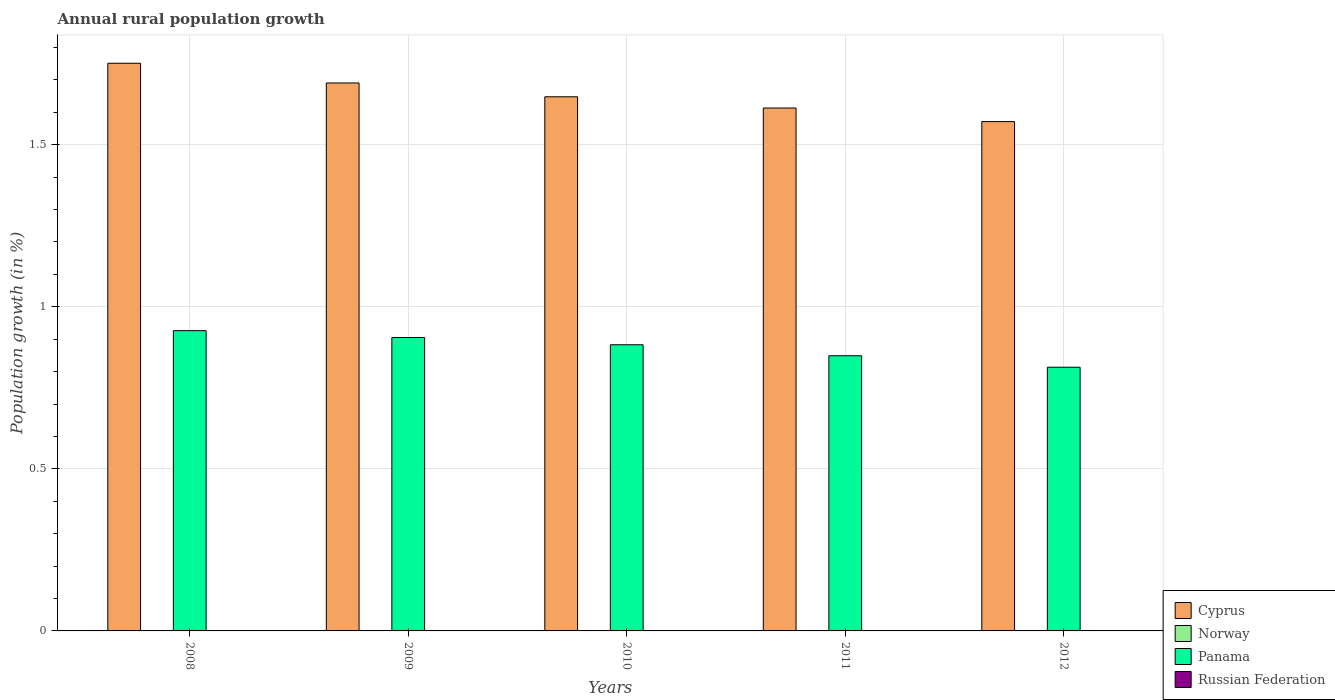How many different coloured bars are there?
Provide a short and direct response. 2. Are the number of bars per tick equal to the number of legend labels?
Offer a terse response. No. How many bars are there on the 2nd tick from the left?
Offer a terse response. 2. How many bars are there on the 4th tick from the right?
Ensure brevity in your answer.  2. Across all years, what is the maximum percentage of rural population growth in Panama?
Provide a succinct answer. 0.93. Across all years, what is the minimum percentage of rural population growth in Panama?
Give a very brief answer. 0.81. What is the difference between the percentage of rural population growth in Panama in 2008 and that in 2012?
Keep it short and to the point. 0.11. What is the difference between the percentage of rural population growth in Norway in 2011 and the percentage of rural population growth in Panama in 2009?
Ensure brevity in your answer.  -0.91. What is the average percentage of rural population growth in Cyprus per year?
Give a very brief answer. 1.65. In the year 2009, what is the difference between the percentage of rural population growth in Panama and percentage of rural population growth in Cyprus?
Provide a short and direct response. -0.79. In how many years, is the percentage of rural population growth in Panama greater than 1.6 %?
Offer a very short reply. 0. What is the ratio of the percentage of rural population growth in Cyprus in 2009 to that in 2012?
Provide a short and direct response. 1.08. Is the percentage of rural population growth in Cyprus in 2008 less than that in 2009?
Your response must be concise. No. Is the difference between the percentage of rural population growth in Panama in 2009 and 2010 greater than the difference between the percentage of rural population growth in Cyprus in 2009 and 2010?
Offer a very short reply. No. What is the difference between the highest and the second highest percentage of rural population growth in Cyprus?
Your answer should be very brief. 0.06. What is the difference between the highest and the lowest percentage of rural population growth in Panama?
Offer a very short reply. 0.11. In how many years, is the percentage of rural population growth in Cyprus greater than the average percentage of rural population growth in Cyprus taken over all years?
Keep it short and to the point. 2. Is the sum of the percentage of rural population growth in Cyprus in 2008 and 2009 greater than the maximum percentage of rural population growth in Panama across all years?
Keep it short and to the point. Yes. Is it the case that in every year, the sum of the percentage of rural population growth in Panama and percentage of rural population growth in Norway is greater than the sum of percentage of rural population growth in Russian Federation and percentage of rural population growth in Cyprus?
Offer a terse response. No. Is it the case that in every year, the sum of the percentage of rural population growth in Cyprus and percentage of rural population growth in Russian Federation is greater than the percentage of rural population growth in Panama?
Provide a short and direct response. Yes. How many years are there in the graph?
Give a very brief answer. 5. Are the values on the major ticks of Y-axis written in scientific E-notation?
Ensure brevity in your answer.  No. Does the graph contain any zero values?
Your response must be concise. Yes. Where does the legend appear in the graph?
Keep it short and to the point. Bottom right. How many legend labels are there?
Your response must be concise. 4. What is the title of the graph?
Your answer should be very brief. Annual rural population growth. What is the label or title of the X-axis?
Provide a short and direct response. Years. What is the label or title of the Y-axis?
Offer a terse response. Population growth (in %). What is the Population growth (in %) in Cyprus in 2008?
Ensure brevity in your answer.  1.75. What is the Population growth (in %) in Norway in 2008?
Offer a terse response. 0. What is the Population growth (in %) of Panama in 2008?
Offer a terse response. 0.93. What is the Population growth (in %) of Russian Federation in 2008?
Offer a terse response. 0. What is the Population growth (in %) of Cyprus in 2009?
Give a very brief answer. 1.69. What is the Population growth (in %) in Panama in 2009?
Offer a very short reply. 0.91. What is the Population growth (in %) in Cyprus in 2010?
Give a very brief answer. 1.65. What is the Population growth (in %) in Norway in 2010?
Your response must be concise. 0. What is the Population growth (in %) in Panama in 2010?
Provide a short and direct response. 0.88. What is the Population growth (in %) of Russian Federation in 2010?
Make the answer very short. 0. What is the Population growth (in %) in Cyprus in 2011?
Keep it short and to the point. 1.61. What is the Population growth (in %) of Panama in 2011?
Provide a short and direct response. 0.85. What is the Population growth (in %) in Cyprus in 2012?
Offer a terse response. 1.57. What is the Population growth (in %) of Panama in 2012?
Keep it short and to the point. 0.81. Across all years, what is the maximum Population growth (in %) of Cyprus?
Keep it short and to the point. 1.75. Across all years, what is the maximum Population growth (in %) in Panama?
Keep it short and to the point. 0.93. Across all years, what is the minimum Population growth (in %) of Cyprus?
Your response must be concise. 1.57. Across all years, what is the minimum Population growth (in %) in Panama?
Make the answer very short. 0.81. What is the total Population growth (in %) in Cyprus in the graph?
Ensure brevity in your answer.  8.27. What is the total Population growth (in %) in Norway in the graph?
Your response must be concise. 0. What is the total Population growth (in %) in Panama in the graph?
Ensure brevity in your answer.  4.38. What is the total Population growth (in %) of Russian Federation in the graph?
Make the answer very short. 0. What is the difference between the Population growth (in %) in Cyprus in 2008 and that in 2009?
Make the answer very short. 0.06. What is the difference between the Population growth (in %) in Panama in 2008 and that in 2009?
Make the answer very short. 0.02. What is the difference between the Population growth (in %) in Cyprus in 2008 and that in 2010?
Offer a terse response. 0.1. What is the difference between the Population growth (in %) of Panama in 2008 and that in 2010?
Keep it short and to the point. 0.04. What is the difference between the Population growth (in %) in Cyprus in 2008 and that in 2011?
Offer a very short reply. 0.14. What is the difference between the Population growth (in %) in Panama in 2008 and that in 2011?
Your answer should be very brief. 0.08. What is the difference between the Population growth (in %) of Cyprus in 2008 and that in 2012?
Your response must be concise. 0.18. What is the difference between the Population growth (in %) in Panama in 2008 and that in 2012?
Provide a succinct answer. 0.11. What is the difference between the Population growth (in %) of Cyprus in 2009 and that in 2010?
Offer a terse response. 0.04. What is the difference between the Population growth (in %) in Panama in 2009 and that in 2010?
Provide a short and direct response. 0.02. What is the difference between the Population growth (in %) in Cyprus in 2009 and that in 2011?
Your answer should be very brief. 0.08. What is the difference between the Population growth (in %) of Panama in 2009 and that in 2011?
Provide a short and direct response. 0.06. What is the difference between the Population growth (in %) of Cyprus in 2009 and that in 2012?
Keep it short and to the point. 0.12. What is the difference between the Population growth (in %) in Panama in 2009 and that in 2012?
Ensure brevity in your answer.  0.09. What is the difference between the Population growth (in %) in Cyprus in 2010 and that in 2011?
Ensure brevity in your answer.  0.03. What is the difference between the Population growth (in %) of Panama in 2010 and that in 2011?
Provide a short and direct response. 0.03. What is the difference between the Population growth (in %) in Cyprus in 2010 and that in 2012?
Your answer should be compact. 0.08. What is the difference between the Population growth (in %) of Panama in 2010 and that in 2012?
Offer a very short reply. 0.07. What is the difference between the Population growth (in %) in Cyprus in 2011 and that in 2012?
Keep it short and to the point. 0.04. What is the difference between the Population growth (in %) in Panama in 2011 and that in 2012?
Give a very brief answer. 0.04. What is the difference between the Population growth (in %) of Cyprus in 2008 and the Population growth (in %) of Panama in 2009?
Give a very brief answer. 0.85. What is the difference between the Population growth (in %) in Cyprus in 2008 and the Population growth (in %) in Panama in 2010?
Offer a terse response. 0.87. What is the difference between the Population growth (in %) in Cyprus in 2008 and the Population growth (in %) in Panama in 2011?
Keep it short and to the point. 0.9. What is the difference between the Population growth (in %) of Cyprus in 2008 and the Population growth (in %) of Panama in 2012?
Ensure brevity in your answer.  0.94. What is the difference between the Population growth (in %) in Cyprus in 2009 and the Population growth (in %) in Panama in 2010?
Provide a succinct answer. 0.81. What is the difference between the Population growth (in %) of Cyprus in 2009 and the Population growth (in %) of Panama in 2011?
Your answer should be compact. 0.84. What is the difference between the Population growth (in %) of Cyprus in 2009 and the Population growth (in %) of Panama in 2012?
Ensure brevity in your answer.  0.88. What is the difference between the Population growth (in %) in Cyprus in 2010 and the Population growth (in %) in Panama in 2011?
Offer a very short reply. 0.8. What is the difference between the Population growth (in %) in Cyprus in 2010 and the Population growth (in %) in Panama in 2012?
Provide a short and direct response. 0.83. What is the difference between the Population growth (in %) of Cyprus in 2011 and the Population growth (in %) of Panama in 2012?
Provide a succinct answer. 0.8. What is the average Population growth (in %) of Cyprus per year?
Offer a very short reply. 1.65. What is the average Population growth (in %) in Panama per year?
Give a very brief answer. 0.88. In the year 2008, what is the difference between the Population growth (in %) of Cyprus and Population growth (in %) of Panama?
Offer a very short reply. 0.82. In the year 2009, what is the difference between the Population growth (in %) in Cyprus and Population growth (in %) in Panama?
Provide a succinct answer. 0.79. In the year 2010, what is the difference between the Population growth (in %) of Cyprus and Population growth (in %) of Panama?
Keep it short and to the point. 0.77. In the year 2011, what is the difference between the Population growth (in %) of Cyprus and Population growth (in %) of Panama?
Your answer should be very brief. 0.76. In the year 2012, what is the difference between the Population growth (in %) of Cyprus and Population growth (in %) of Panama?
Ensure brevity in your answer.  0.76. What is the ratio of the Population growth (in %) of Cyprus in 2008 to that in 2009?
Provide a short and direct response. 1.04. What is the ratio of the Population growth (in %) of Panama in 2008 to that in 2009?
Make the answer very short. 1.02. What is the ratio of the Population growth (in %) in Cyprus in 2008 to that in 2010?
Offer a terse response. 1.06. What is the ratio of the Population growth (in %) in Panama in 2008 to that in 2010?
Your answer should be very brief. 1.05. What is the ratio of the Population growth (in %) in Cyprus in 2008 to that in 2011?
Offer a very short reply. 1.09. What is the ratio of the Population growth (in %) of Panama in 2008 to that in 2011?
Ensure brevity in your answer.  1.09. What is the ratio of the Population growth (in %) of Cyprus in 2008 to that in 2012?
Your answer should be compact. 1.11. What is the ratio of the Population growth (in %) in Panama in 2008 to that in 2012?
Your response must be concise. 1.14. What is the ratio of the Population growth (in %) in Cyprus in 2009 to that in 2010?
Provide a short and direct response. 1.03. What is the ratio of the Population growth (in %) of Panama in 2009 to that in 2010?
Keep it short and to the point. 1.03. What is the ratio of the Population growth (in %) in Cyprus in 2009 to that in 2011?
Your answer should be compact. 1.05. What is the ratio of the Population growth (in %) of Panama in 2009 to that in 2011?
Provide a short and direct response. 1.07. What is the ratio of the Population growth (in %) in Cyprus in 2009 to that in 2012?
Your answer should be very brief. 1.08. What is the ratio of the Population growth (in %) of Panama in 2009 to that in 2012?
Ensure brevity in your answer.  1.11. What is the ratio of the Population growth (in %) in Cyprus in 2010 to that in 2011?
Offer a terse response. 1.02. What is the ratio of the Population growth (in %) in Panama in 2010 to that in 2011?
Offer a very short reply. 1.04. What is the ratio of the Population growth (in %) in Cyprus in 2010 to that in 2012?
Offer a terse response. 1.05. What is the ratio of the Population growth (in %) in Panama in 2010 to that in 2012?
Your answer should be compact. 1.09. What is the ratio of the Population growth (in %) of Cyprus in 2011 to that in 2012?
Provide a succinct answer. 1.03. What is the ratio of the Population growth (in %) in Panama in 2011 to that in 2012?
Provide a succinct answer. 1.04. What is the difference between the highest and the second highest Population growth (in %) in Cyprus?
Your answer should be very brief. 0.06. What is the difference between the highest and the second highest Population growth (in %) of Panama?
Offer a very short reply. 0.02. What is the difference between the highest and the lowest Population growth (in %) in Cyprus?
Give a very brief answer. 0.18. What is the difference between the highest and the lowest Population growth (in %) of Panama?
Your answer should be very brief. 0.11. 